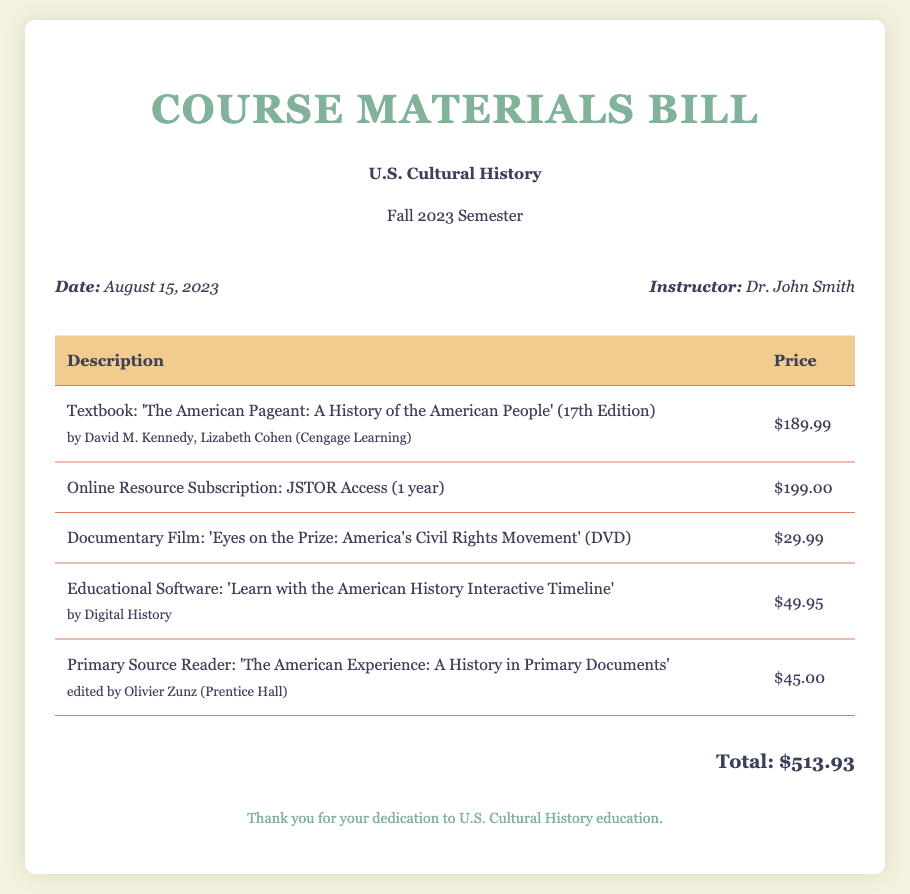What is the date of the bill? The date of the bill is explicitly stated in the document, which is August 15, 2023.
Answer: August 15, 2023 Who is the instructor for the course? The document specifies the instructor's name, which is Dr. John Smith.
Answer: Dr. John Smith What is the price of the textbook? The price for the textbook is listed in the table, which is $189.99.
Answer: $189.99 How much does the online resource subscription cost? The document provides the cost of the online resource subscription, which is $199.00.
Answer: $199.00 What is the total cost of all course materials? The total cost is summed up in the document, indicated as $513.93.
Answer: $513.93 How many primary documents are included in the reader? The document does not specify the number of primary documents but lists the title and provides its price.
Answer: Not specified What educational software is mentioned in the bill? The bill mentions the educational software 'Learn with the American History Interactive Timeline.'
Answer: Learn with the American History Interactive Timeline What is the title of the documentary film? The title of the documentary film is provided in the bill, which is 'Eyes on the Prize: America's Civil Rights Movement.'
Answer: Eyes on the Prize: America's Civil Rights Movement What edition is the textbook? The edition of the textbook is clearly indicated in the document as the 17th Edition.
Answer: 17th Edition 